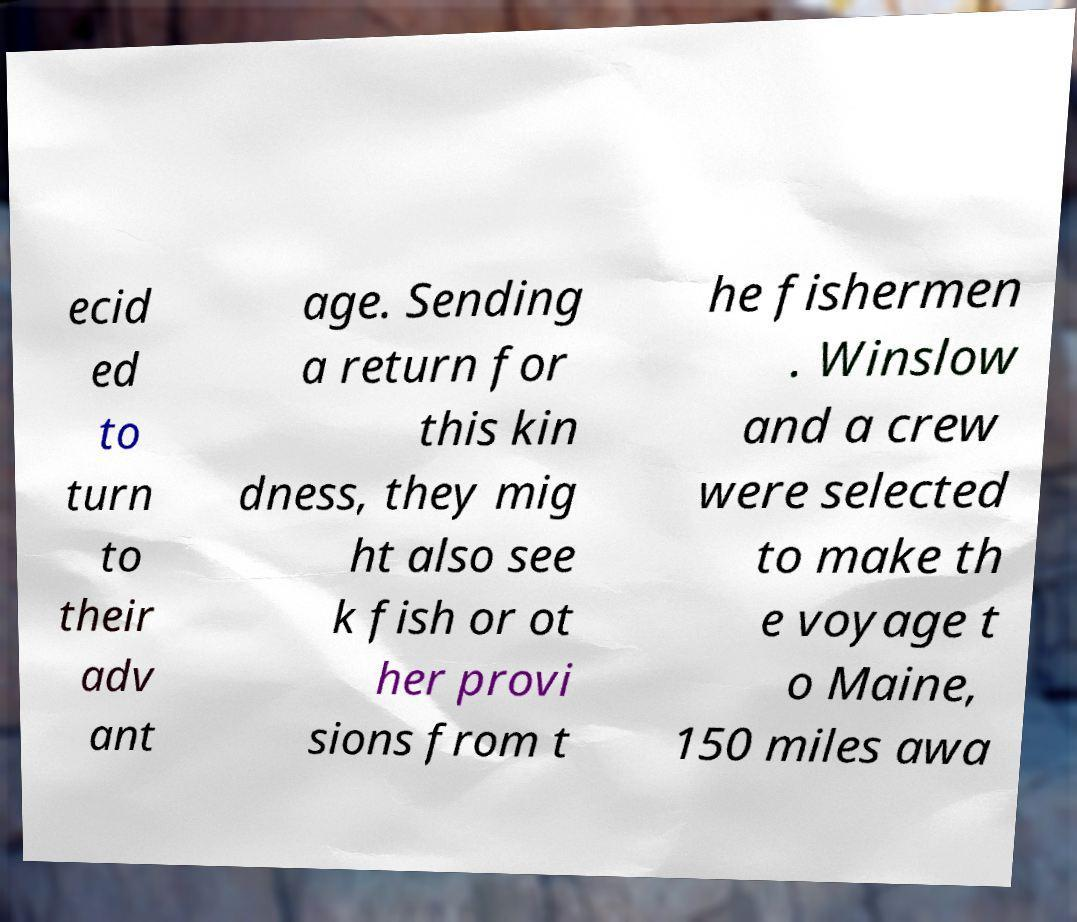Could you extract and type out the text from this image? ecid ed to turn to their adv ant age. Sending a return for this kin dness, they mig ht also see k fish or ot her provi sions from t he fishermen . Winslow and a crew were selected to make th e voyage t o Maine, 150 miles awa 